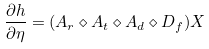<formula> <loc_0><loc_0><loc_500><loc_500>\frac { \partial h } { \partial \eta } = ( A _ { r } \diamond A _ { t } \diamond A _ { d } \diamond D _ { f } ) X</formula> 